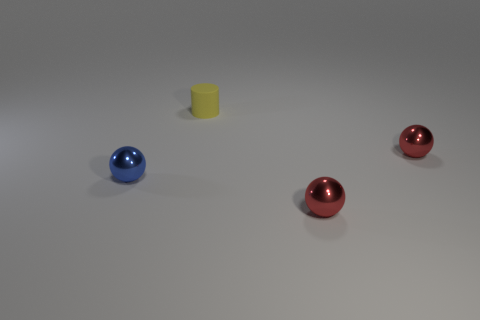What size is the blue metallic thing?
Offer a terse response. Small. What number of small red objects have the same material as the small blue ball?
Offer a very short reply. 2. There is a tiny rubber cylinder; is it the same color as the small shiny thing on the left side of the yellow matte cylinder?
Make the answer very short. No. There is a tiny metallic object right of the tiny shiny object in front of the small blue thing; what is its color?
Keep it short and to the point. Red. What is the color of the other matte object that is the same size as the blue object?
Ensure brevity in your answer.  Yellow. Is there a large purple rubber thing of the same shape as the tiny yellow matte object?
Give a very brief answer. No. What is the shape of the small yellow object?
Your answer should be very brief. Cylinder. Is the number of small yellow rubber things to the left of the tiny blue thing greater than the number of yellow matte objects that are to the left of the tiny yellow rubber cylinder?
Give a very brief answer. No. What number of other objects are the same size as the yellow object?
Your answer should be compact. 3. What is the tiny thing that is both in front of the small yellow matte thing and behind the tiny blue ball made of?
Your answer should be very brief. Metal. 